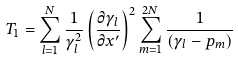<formula> <loc_0><loc_0><loc_500><loc_500>T _ { 1 } = \sum _ { l = 1 } ^ { N } \frac { 1 } { \gamma _ { l } ^ { 2 } } \left ( \frac { \partial \gamma _ { l } } { \partial x ^ { \prime } } \right ) ^ { 2 } \sum _ { m = 1 } ^ { 2 N } \frac { 1 } { \left ( \gamma _ { l } - p _ { m } \right ) }</formula> 